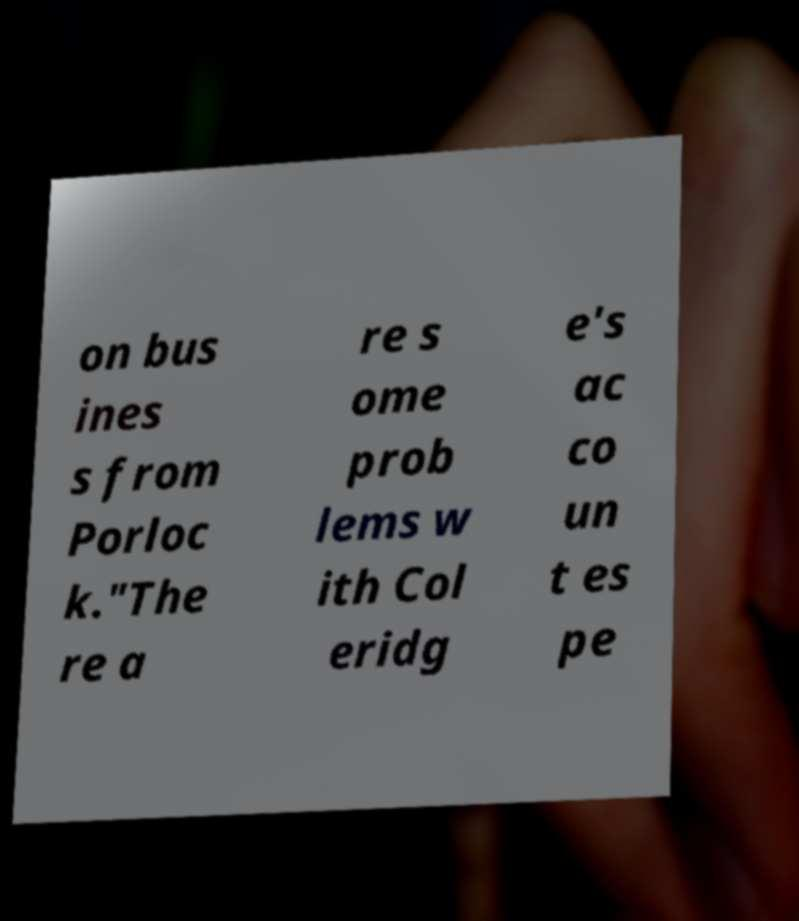Can you read and provide the text displayed in the image?This photo seems to have some interesting text. Can you extract and type it out for me? on bus ines s from Porloc k."The re a re s ome prob lems w ith Col eridg e's ac co un t es pe 